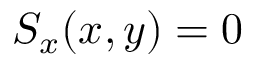<formula> <loc_0><loc_0><loc_500><loc_500>S _ { x } ( x , y ) = 0</formula> 